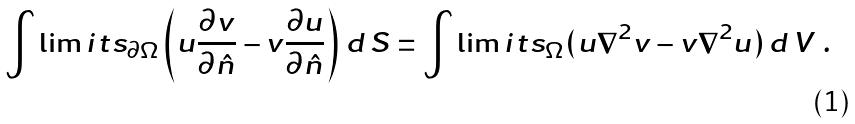<formula> <loc_0><loc_0><loc_500><loc_500>\int \lim i t s _ { \partial \Omega } \left ( u \frac { \partial v } { \partial \hat { n } } - v \frac { \partial u } { \partial \hat { n } } \right ) \, d \, S = \int \lim i t s _ { \Omega } ( u { \nabla } ^ { 2 } v - v { \nabla } ^ { 2 } u ) \, d \, V \ .</formula> 